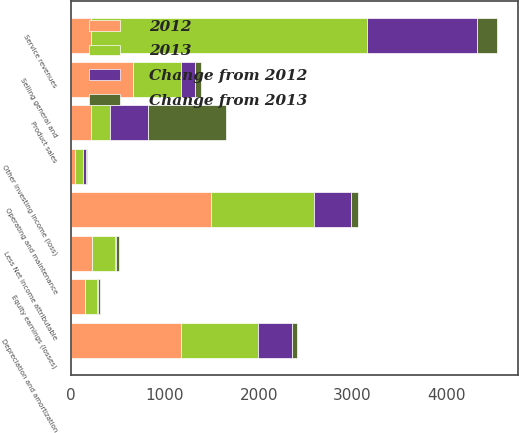Convert chart. <chart><loc_0><loc_0><loc_500><loc_500><stacked_bar_chart><ecel><fcel>Service revenues<fcel>Product sales<fcel>Operating and maintenance<fcel>Depreciation and amortization<fcel>Selling general and<fcel>Equity earnings (losses)<fcel>Other investing income (loss)<fcel>Less Net income attributable<nl><fcel>2012<fcel>210<fcel>210<fcel>1492<fcel>1176<fcel>661<fcel>144<fcel>43<fcel>225<nl><fcel>Change from 2012<fcel>1177<fcel>400<fcel>395<fcel>361<fcel>149<fcel>10<fcel>38<fcel>13<nl><fcel>2013<fcel>2939<fcel>210<fcel>1097<fcel>815<fcel>512<fcel>134<fcel>81<fcel>238<nl><fcel>Change from 2013<fcel>210<fcel>836<fcel>70<fcel>59<fcel>59<fcel>23<fcel>4<fcel>32<nl></chart> 